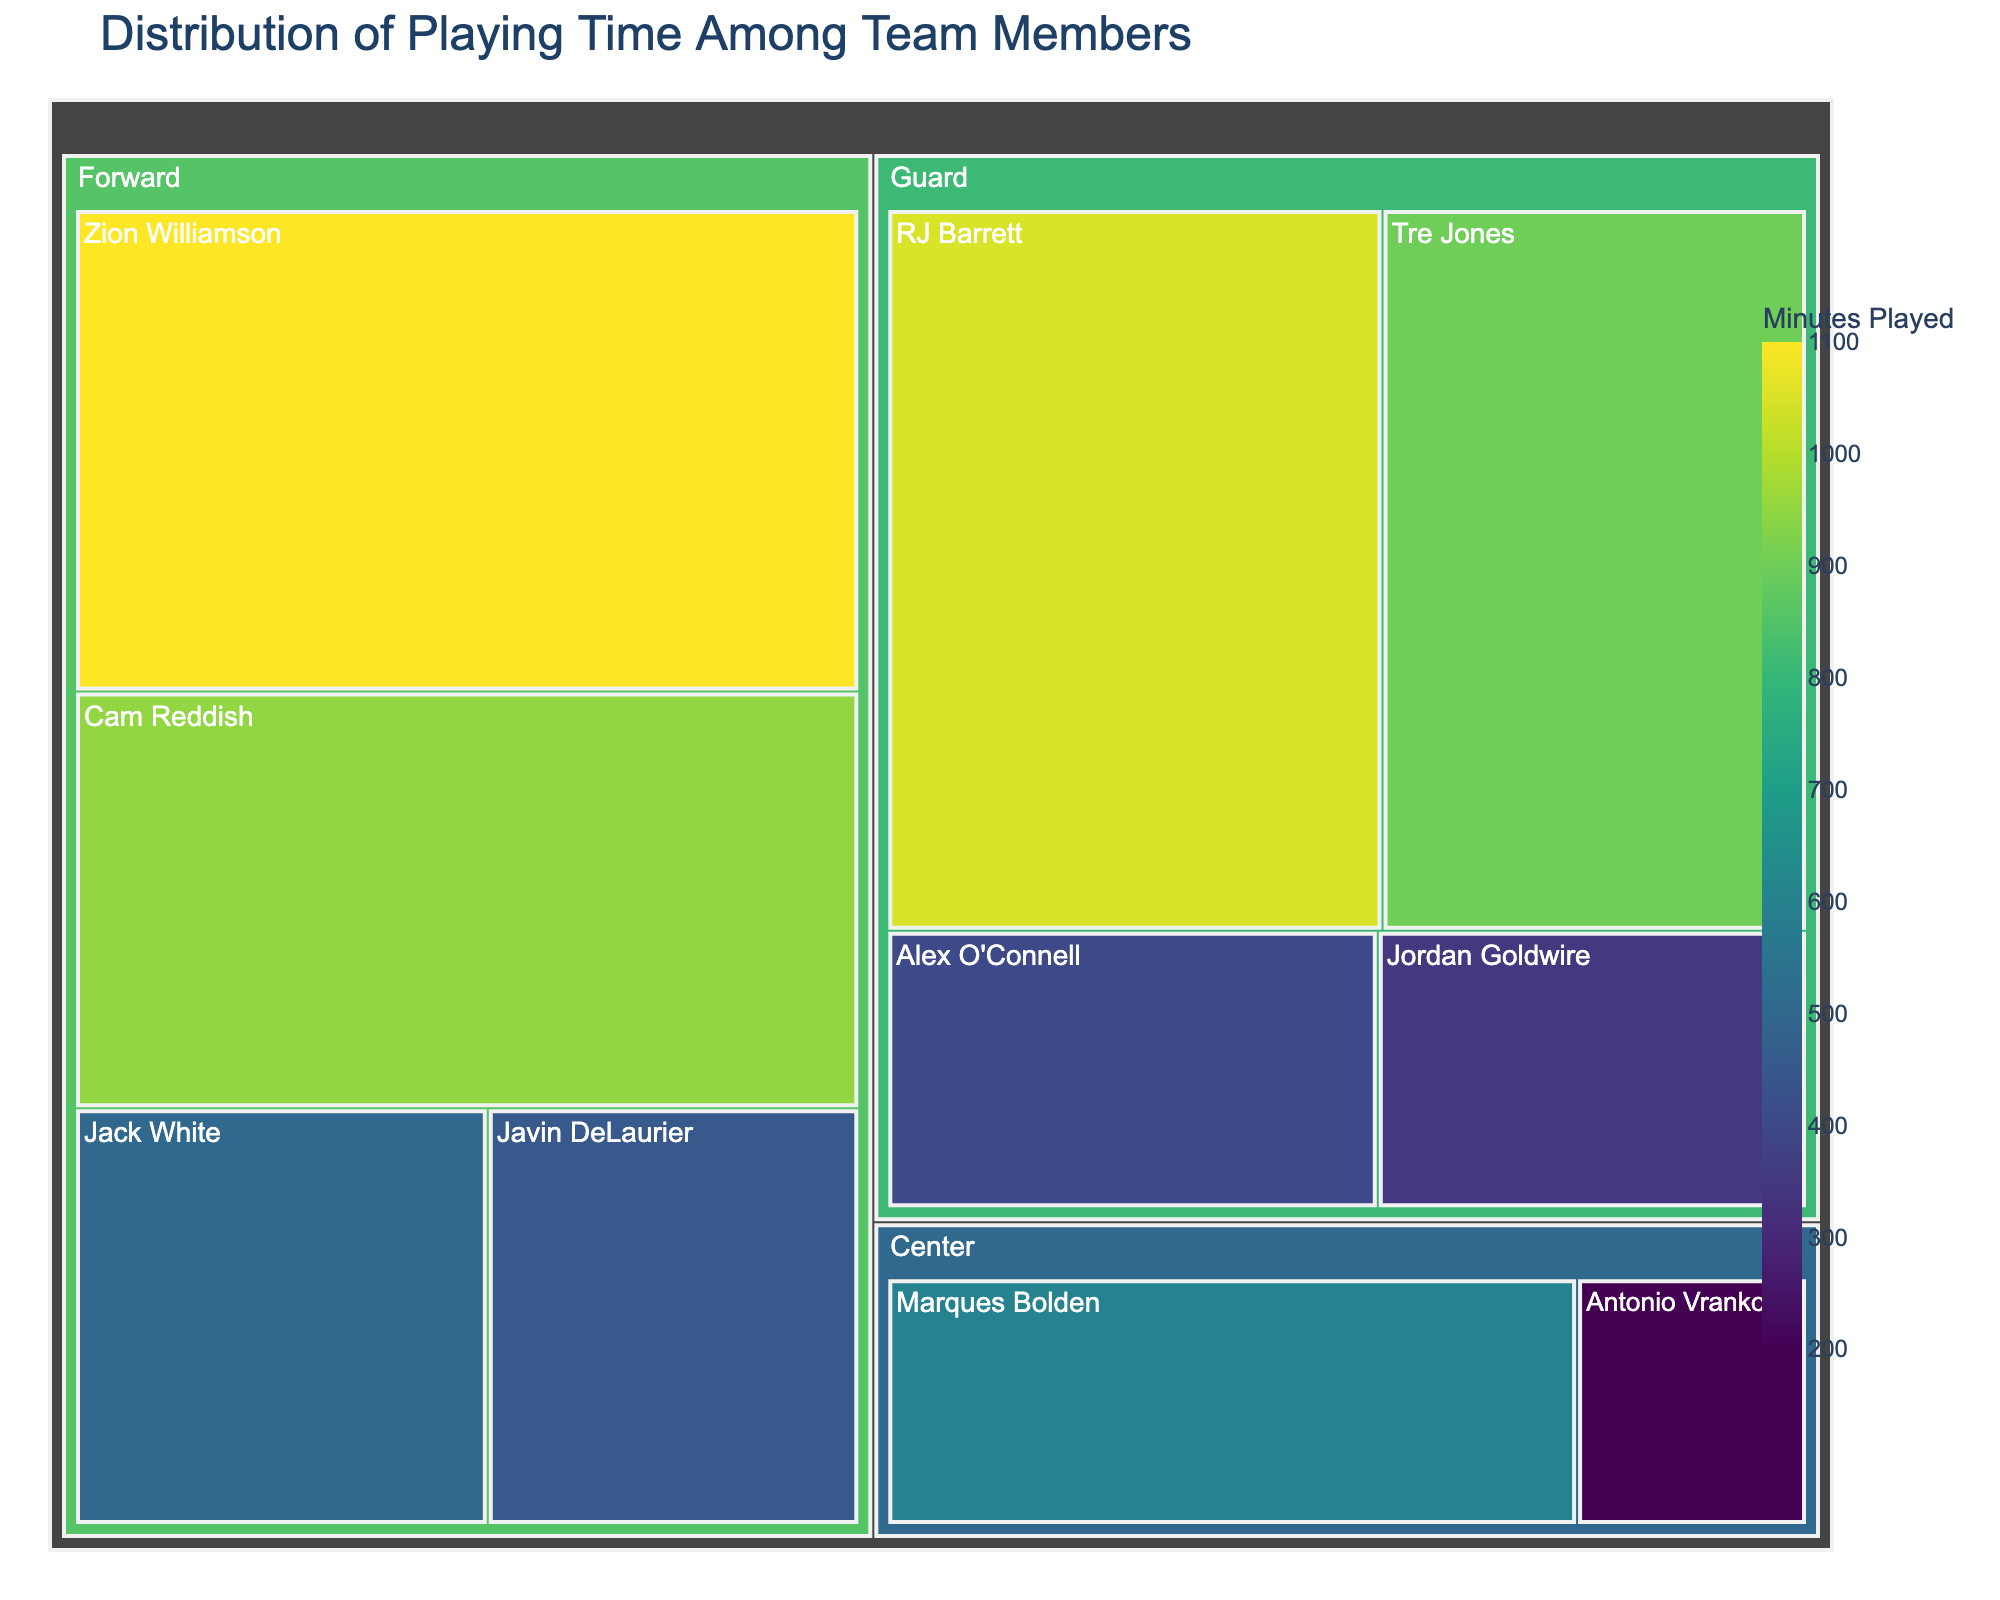What is the title of the figure? The title is the text displayed at the top of the figure, providing an overview of the data being visualized. In this case, it states the context of the treemap.
Answer: Distribution of Playing Time Among Team Members Which player has the highest playing time? By looking at the treemap, the largest segment representing a player will indicate the highest playing time. In this case, it is Zion Williamson.
Answer: Zion Williamson What is the playing time for Marques Bolden? The segment representing Marques Bolden in the treemap will have a label or hover data indicating his minutes played.
Answer: 600 minutes What is the total playing time for all Guards? Sum the minutes played by all players listed as Guards: RJ Barrett (1050), Tre Jones (900), Alex O'Connell (400), Jordan Goldwire (350). Adding these gives 1050 + 900 + 400 + 350.
Answer: 2700 minutes How does Zion Williamson's playing time compare to RJ Barrett's? Compare the size or the value of the segments for Zion Williamson and RJ Barrett in the treemap. Zion Williamson has 1100 minutes while RJ Barrett has 1050.
Answer: Zion Williamson played 50 minutes more than RJ Barrett What positions have the highest and lowest total playing time? Sum the playing times for each position and compare. Forwards: 1100 + 950 + 500 + 450 = 3000. Guards: 1050 + 900 + 400 + 350 = 2700. Centers: 600 + 200 = 800.
Answer: Highest: Forwards, Lowest: Centers What is the average playing time for the forwards? Sum the playing times for all forwards and divide by the number of forwards: (1100 + 950 + 500 + 450) / 4. This is (3000 / 4).
Answer: 750 minutes How much more did the player with the most minutes play compared to the player with the fewest minutes? Find the difference between the highest (Zion Williamson: 1100) and lowest (Antonio Vrankovic: 200) playing times. 1100 - 200.
Answer: 900 minutes What is the combined playing time for Jack White and Javin DeLaurier? Sum the minutes played by both Jack White and Javin DeLaurier. Jack White has 500 and Javin DeLaurier has 450. So, 500 + 450.
Answer: 950 minutes Which player has the second highest playing time? After Zion Williamson, the next largest segment for an individual player represents the second highest playing time. This is RJ Barrett with 1050 minutes.
Answer: RJ Barrett 